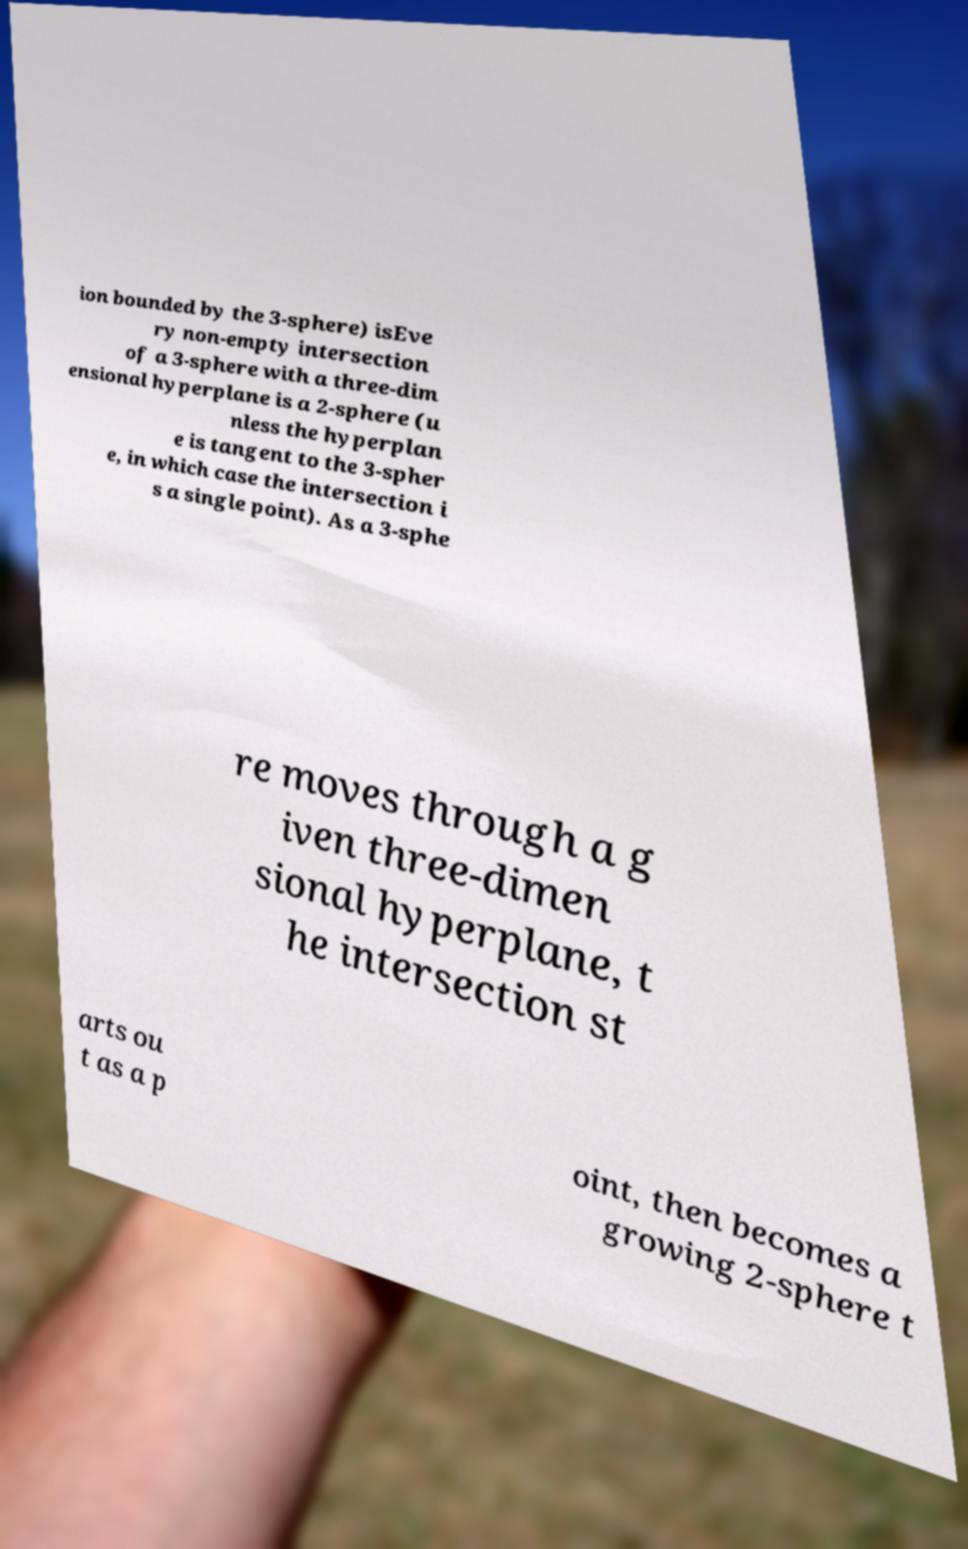For documentation purposes, I need the text within this image transcribed. Could you provide that? ion bounded by the 3-sphere) isEve ry non-empty intersection of a 3-sphere with a three-dim ensional hyperplane is a 2-sphere (u nless the hyperplan e is tangent to the 3-spher e, in which case the intersection i s a single point). As a 3-sphe re moves through a g iven three-dimen sional hyperplane, t he intersection st arts ou t as a p oint, then becomes a growing 2-sphere t 